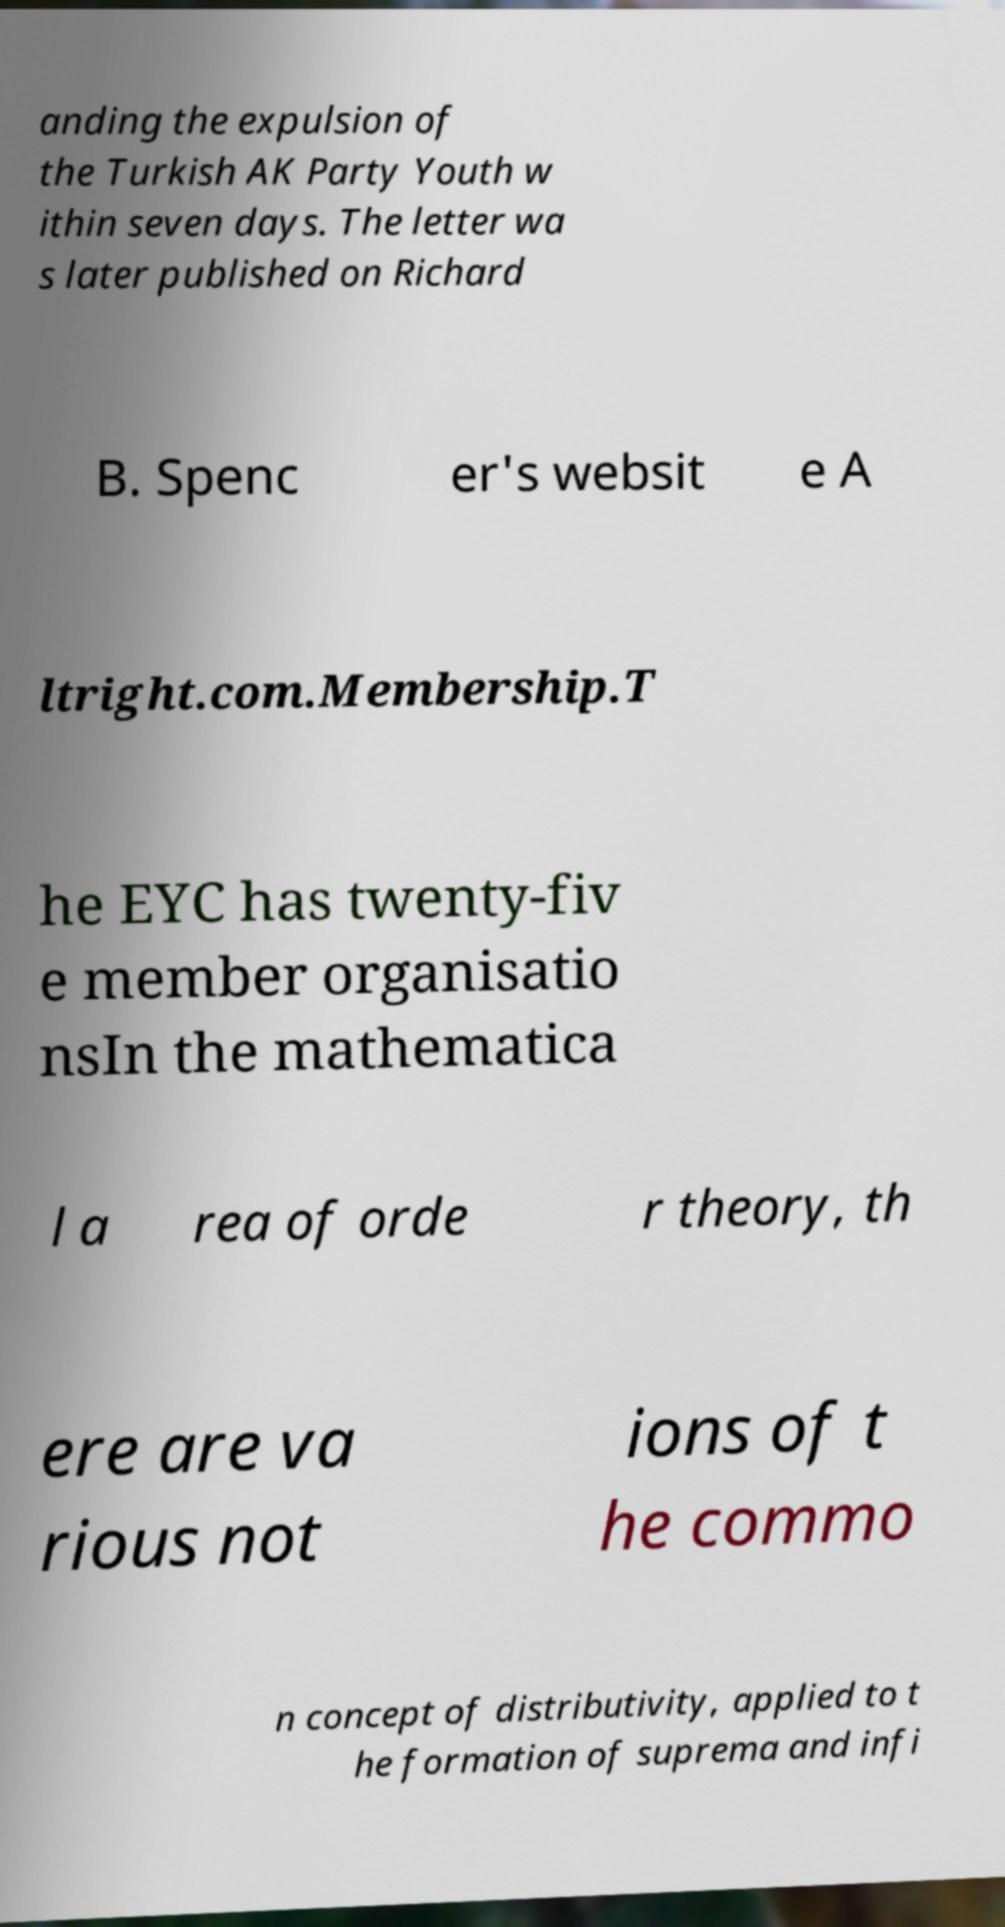Please read and relay the text visible in this image. What does it say? anding the expulsion of the Turkish AK Party Youth w ithin seven days. The letter wa s later published on Richard B. Spenc er's websit e A ltright.com.Membership.T he EYC has twenty-fiv e member organisatio nsIn the mathematica l a rea of orde r theory, th ere are va rious not ions of t he commo n concept of distributivity, applied to t he formation of suprema and infi 